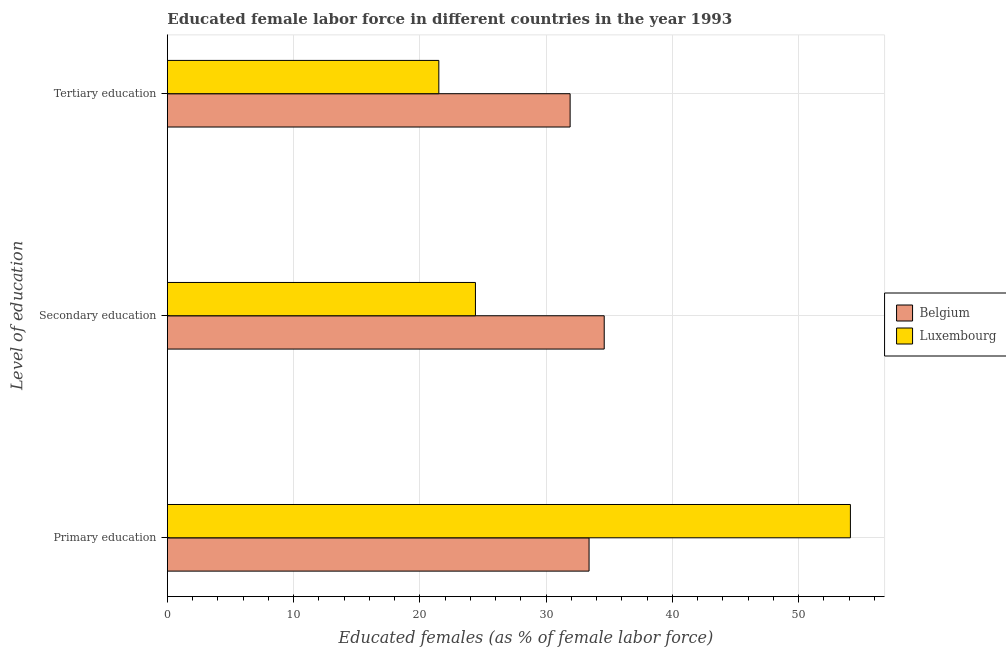How many different coloured bars are there?
Your answer should be compact. 2. Are the number of bars on each tick of the Y-axis equal?
Ensure brevity in your answer.  Yes. What is the label of the 2nd group of bars from the top?
Give a very brief answer. Secondary education. What is the percentage of female labor force who received tertiary education in Belgium?
Offer a terse response. 31.9. Across all countries, what is the maximum percentage of female labor force who received tertiary education?
Provide a short and direct response. 31.9. Across all countries, what is the minimum percentage of female labor force who received secondary education?
Your response must be concise. 24.4. What is the total percentage of female labor force who received primary education in the graph?
Provide a short and direct response. 87.5. What is the difference between the percentage of female labor force who received tertiary education in Luxembourg and that in Belgium?
Your answer should be very brief. -10.4. What is the difference between the percentage of female labor force who received tertiary education in Belgium and the percentage of female labor force who received primary education in Luxembourg?
Your answer should be very brief. -22.2. What is the average percentage of female labor force who received tertiary education per country?
Ensure brevity in your answer.  26.7. What is the difference between the percentage of female labor force who received primary education and percentage of female labor force who received secondary education in Belgium?
Provide a short and direct response. -1.2. What is the ratio of the percentage of female labor force who received tertiary education in Belgium to that in Luxembourg?
Ensure brevity in your answer.  1.48. Is the percentage of female labor force who received secondary education in Luxembourg less than that in Belgium?
Your answer should be compact. Yes. Is the difference between the percentage of female labor force who received tertiary education in Belgium and Luxembourg greater than the difference between the percentage of female labor force who received secondary education in Belgium and Luxembourg?
Your response must be concise. Yes. What is the difference between the highest and the second highest percentage of female labor force who received primary education?
Your answer should be very brief. 20.7. What is the difference between the highest and the lowest percentage of female labor force who received secondary education?
Your answer should be very brief. 10.2. What does the 1st bar from the top in Secondary education represents?
Your response must be concise. Luxembourg. What does the 2nd bar from the bottom in Secondary education represents?
Ensure brevity in your answer.  Luxembourg. Are all the bars in the graph horizontal?
Your response must be concise. Yes. What is the difference between two consecutive major ticks on the X-axis?
Keep it short and to the point. 10. Does the graph contain grids?
Provide a short and direct response. Yes. Where does the legend appear in the graph?
Make the answer very short. Center right. What is the title of the graph?
Keep it short and to the point. Educated female labor force in different countries in the year 1993. What is the label or title of the X-axis?
Offer a very short reply. Educated females (as % of female labor force). What is the label or title of the Y-axis?
Give a very brief answer. Level of education. What is the Educated females (as % of female labor force) in Belgium in Primary education?
Provide a succinct answer. 33.4. What is the Educated females (as % of female labor force) of Luxembourg in Primary education?
Offer a very short reply. 54.1. What is the Educated females (as % of female labor force) of Belgium in Secondary education?
Ensure brevity in your answer.  34.6. What is the Educated females (as % of female labor force) in Luxembourg in Secondary education?
Your answer should be compact. 24.4. What is the Educated females (as % of female labor force) of Belgium in Tertiary education?
Offer a terse response. 31.9. What is the Educated females (as % of female labor force) of Luxembourg in Tertiary education?
Ensure brevity in your answer.  21.5. Across all Level of education, what is the maximum Educated females (as % of female labor force) in Belgium?
Offer a very short reply. 34.6. Across all Level of education, what is the maximum Educated females (as % of female labor force) in Luxembourg?
Provide a short and direct response. 54.1. Across all Level of education, what is the minimum Educated females (as % of female labor force) in Belgium?
Provide a short and direct response. 31.9. What is the total Educated females (as % of female labor force) in Belgium in the graph?
Make the answer very short. 99.9. What is the total Educated females (as % of female labor force) in Luxembourg in the graph?
Provide a short and direct response. 100. What is the difference between the Educated females (as % of female labor force) in Luxembourg in Primary education and that in Secondary education?
Offer a terse response. 29.7. What is the difference between the Educated females (as % of female labor force) in Belgium in Primary education and that in Tertiary education?
Keep it short and to the point. 1.5. What is the difference between the Educated females (as % of female labor force) of Luxembourg in Primary education and that in Tertiary education?
Your answer should be very brief. 32.6. What is the difference between the Educated females (as % of female labor force) in Belgium in Primary education and the Educated females (as % of female labor force) in Luxembourg in Secondary education?
Your answer should be very brief. 9. What is the difference between the Educated females (as % of female labor force) of Belgium in Secondary education and the Educated females (as % of female labor force) of Luxembourg in Tertiary education?
Give a very brief answer. 13.1. What is the average Educated females (as % of female labor force) of Belgium per Level of education?
Offer a very short reply. 33.3. What is the average Educated females (as % of female labor force) in Luxembourg per Level of education?
Provide a succinct answer. 33.33. What is the difference between the Educated females (as % of female labor force) of Belgium and Educated females (as % of female labor force) of Luxembourg in Primary education?
Your answer should be compact. -20.7. What is the difference between the Educated females (as % of female labor force) of Belgium and Educated females (as % of female labor force) of Luxembourg in Secondary education?
Offer a very short reply. 10.2. What is the ratio of the Educated females (as % of female labor force) of Belgium in Primary education to that in Secondary education?
Provide a succinct answer. 0.97. What is the ratio of the Educated females (as % of female labor force) in Luxembourg in Primary education to that in Secondary education?
Provide a short and direct response. 2.22. What is the ratio of the Educated females (as % of female labor force) of Belgium in Primary education to that in Tertiary education?
Your answer should be compact. 1.05. What is the ratio of the Educated females (as % of female labor force) in Luxembourg in Primary education to that in Tertiary education?
Provide a succinct answer. 2.52. What is the ratio of the Educated females (as % of female labor force) of Belgium in Secondary education to that in Tertiary education?
Offer a very short reply. 1.08. What is the ratio of the Educated females (as % of female labor force) in Luxembourg in Secondary education to that in Tertiary education?
Provide a short and direct response. 1.13. What is the difference between the highest and the second highest Educated females (as % of female labor force) in Belgium?
Your response must be concise. 1.2. What is the difference between the highest and the second highest Educated females (as % of female labor force) in Luxembourg?
Make the answer very short. 29.7. What is the difference between the highest and the lowest Educated females (as % of female labor force) in Belgium?
Ensure brevity in your answer.  2.7. What is the difference between the highest and the lowest Educated females (as % of female labor force) in Luxembourg?
Keep it short and to the point. 32.6. 